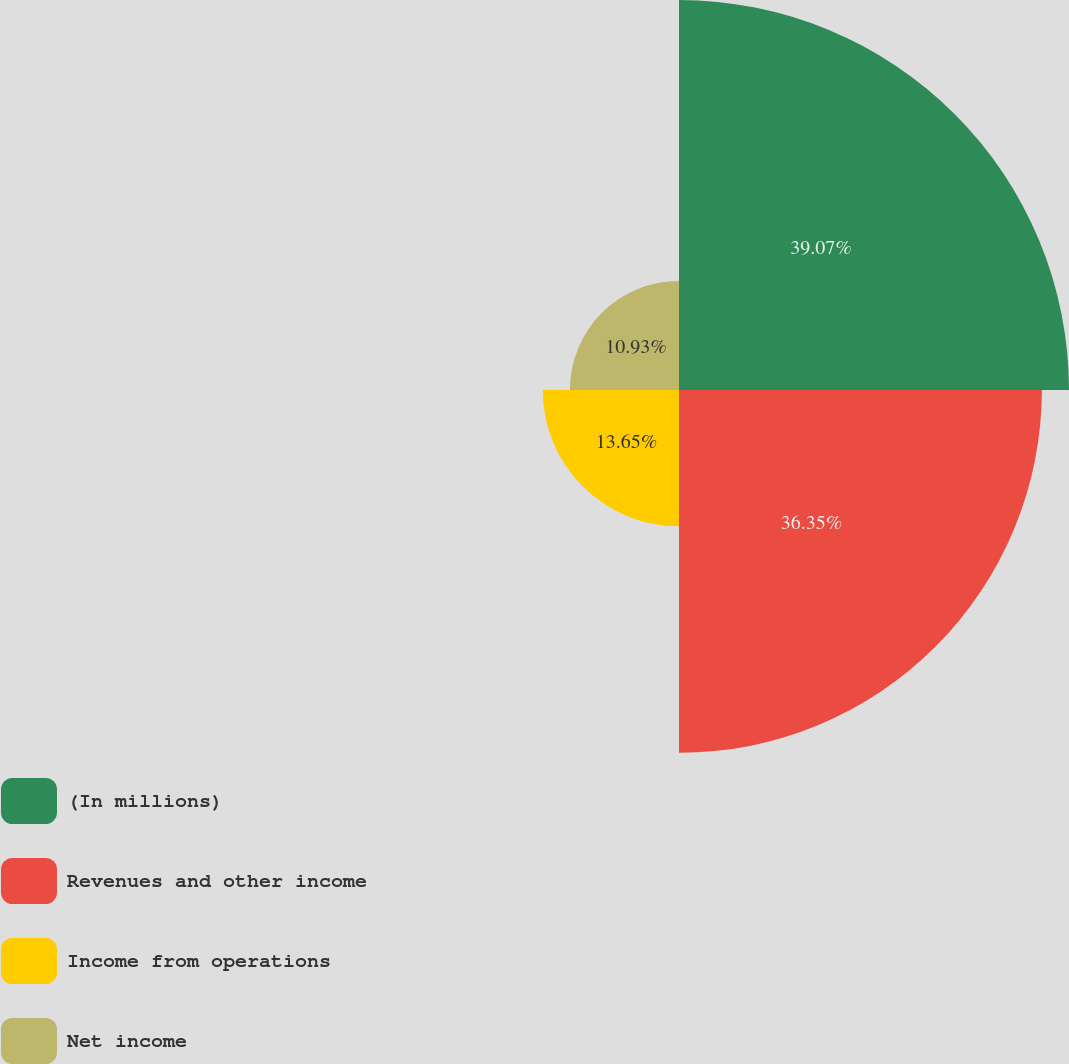Convert chart. <chart><loc_0><loc_0><loc_500><loc_500><pie_chart><fcel>(In millions)<fcel>Revenues and other income<fcel>Income from operations<fcel>Net income<nl><fcel>39.07%<fcel>36.35%<fcel>13.65%<fcel>10.93%<nl></chart> 